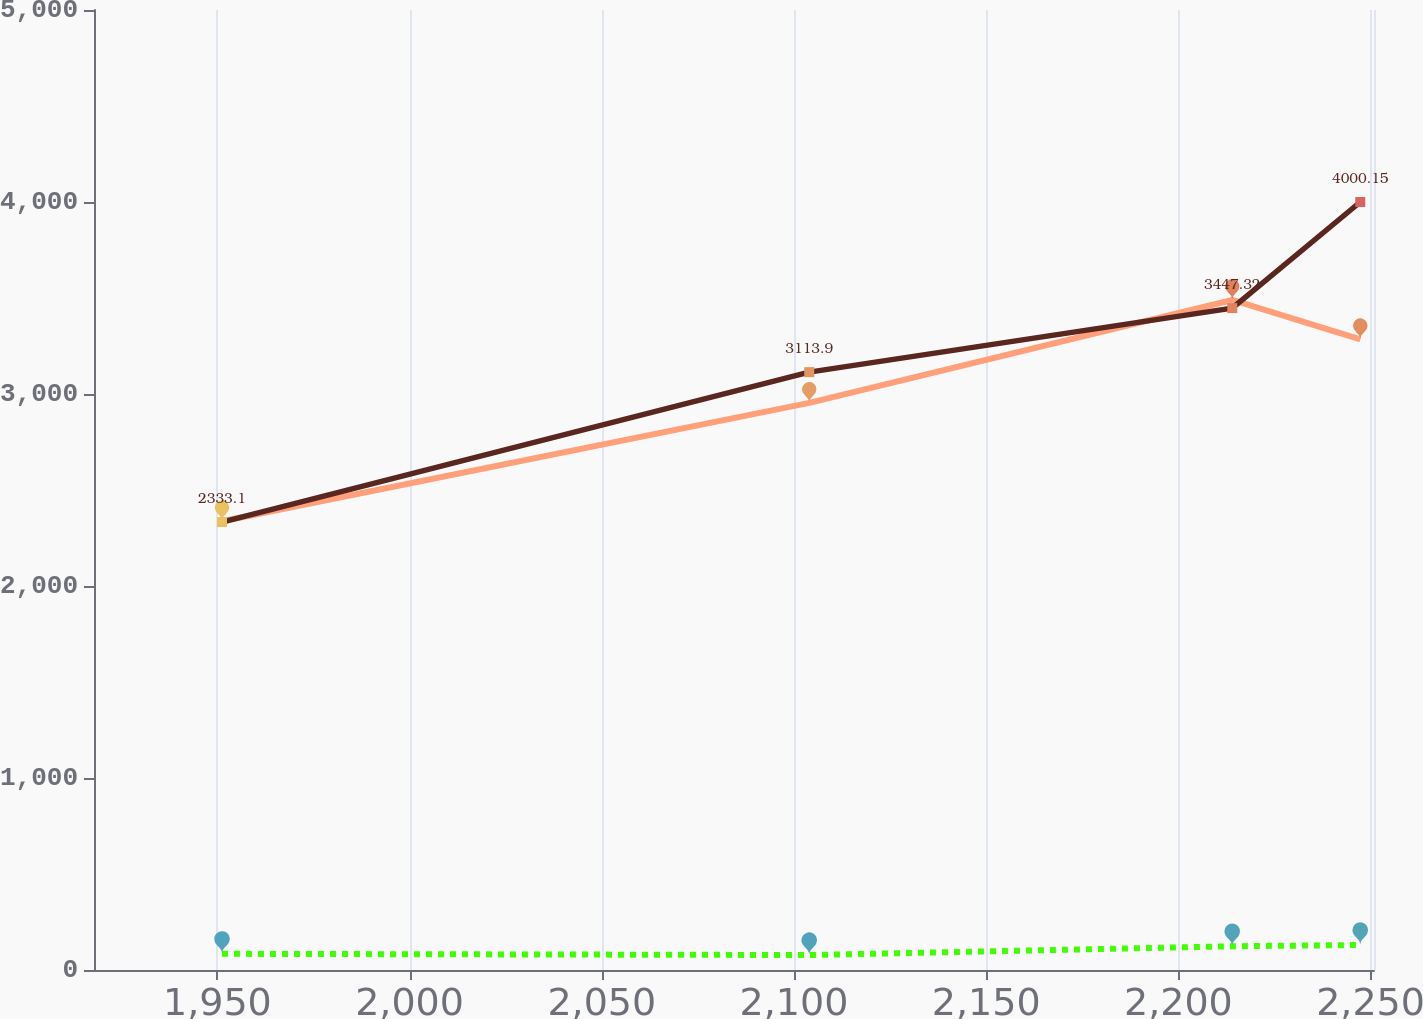Convert chart to OTSL. <chart><loc_0><loc_0><loc_500><loc_500><line_chart><ecel><fcel>Expected Subsidy Receipts<fcel>Net Benefit Payments<fcel>Benefit Payments<nl><fcel>1951.2<fcel>2337.45<fcel>84.27<fcel>2333.1<nl><fcel>2103.97<fcel>2953.89<fcel>77.9<fcel>3113.9<nl><fcel>2214.02<fcel>3489.68<fcel>123.73<fcel>3447.32<nl><fcel>2247.32<fcel>3284.92<fcel>130.1<fcel>4000.15<nl><fcel>2284.19<fcel>4385<fcel>141.64<fcel>3280.61<nl></chart> 